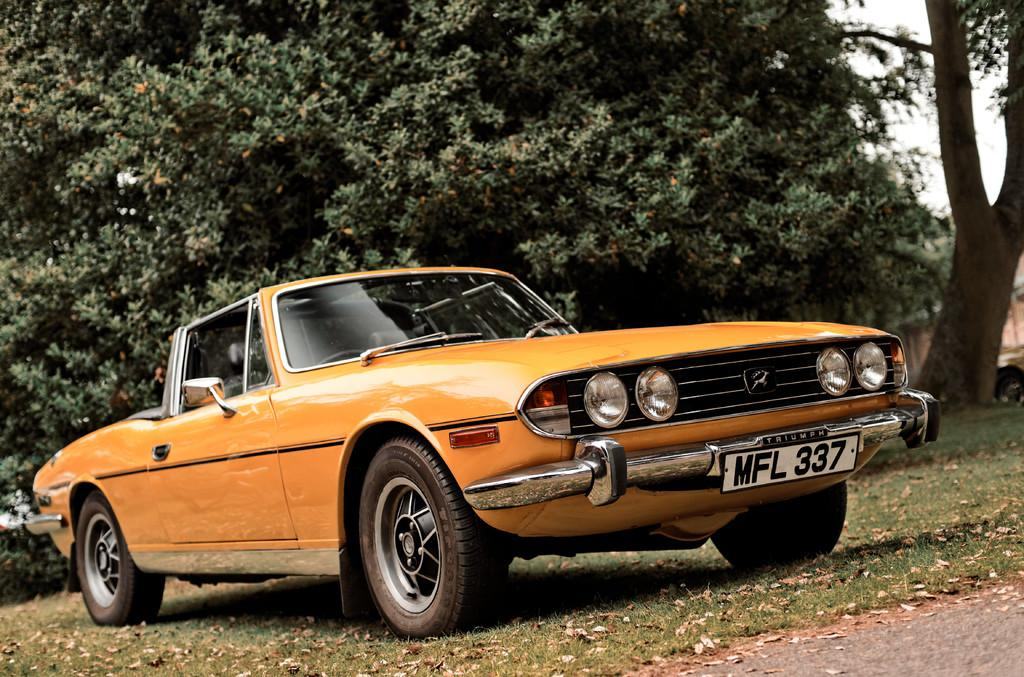What color is the car in the image? The car in the image is orange. Can you identify any specific features of the car? Yes, the car has a visible number plate. Where is the car located in the image? The car is on the ground in the image. What can be seen in the background of the image? There are many trees and the sky visible in the background of the image. What type of whip is being used by the children in the image? There are no children or whips present in the image; it features an orange car on the ground with a visible number plate. What material is the tin used for in the image? There is no tin present in the image. 